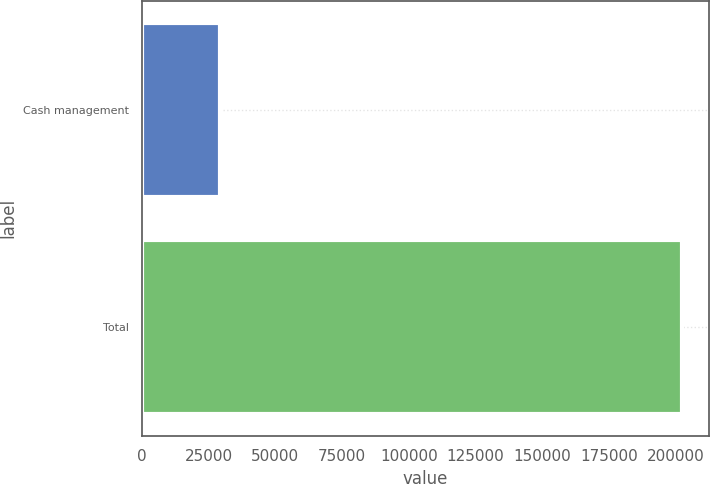Convert chart to OTSL. <chart><loc_0><loc_0><loc_500><loc_500><bar_chart><fcel>Cash management<fcel>Total<nl><fcel>29228<fcel>202191<nl></chart> 